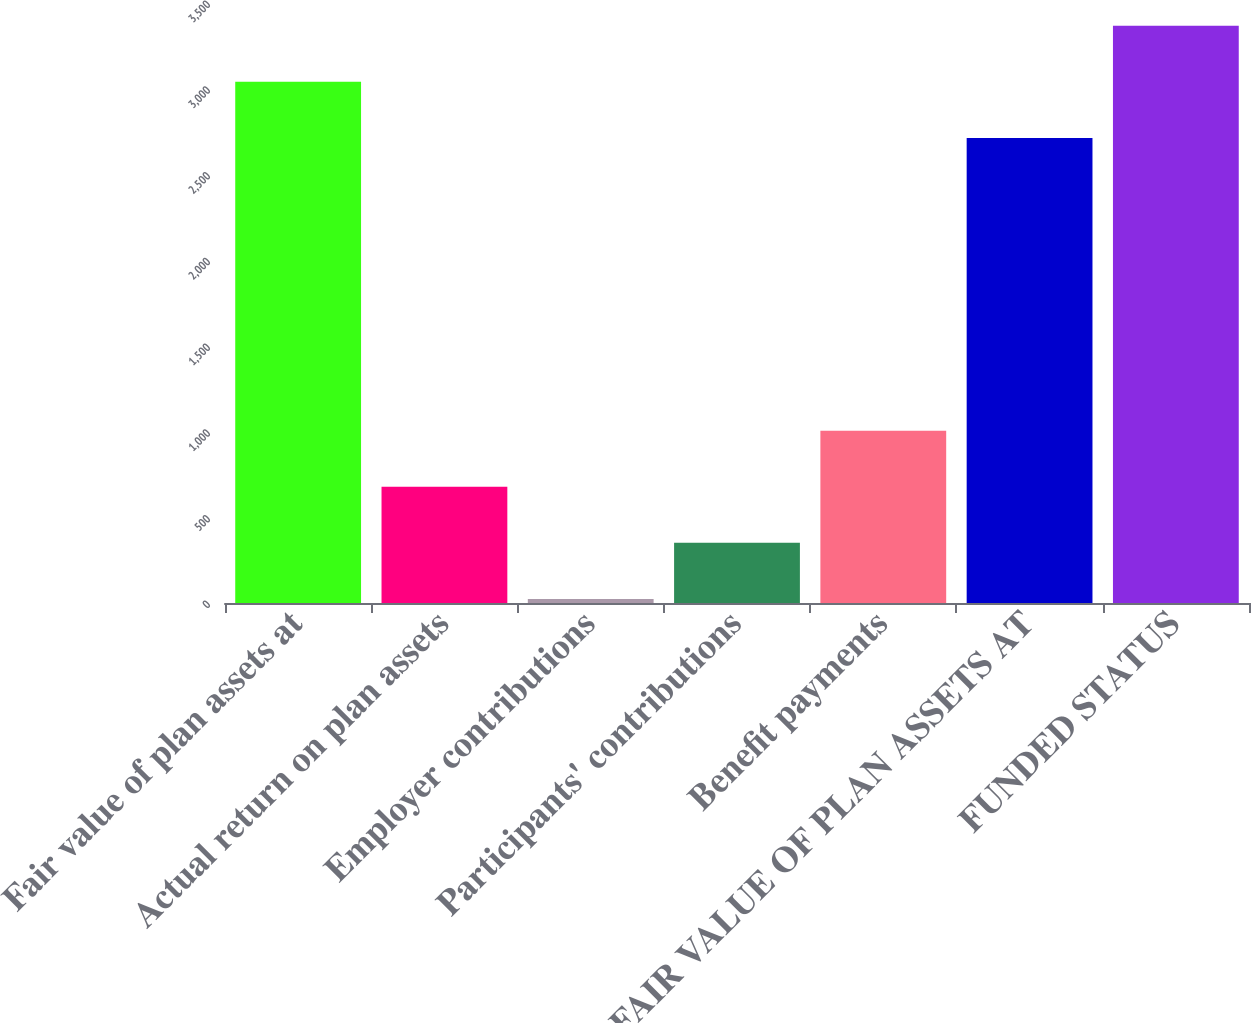<chart> <loc_0><loc_0><loc_500><loc_500><bar_chart><fcel>Fair value of plan assets at<fcel>Actual return on plan assets<fcel>Employer contributions<fcel>Participants' contributions<fcel>Benefit payments<fcel>FAIR VALUE OF PLAN ASSETS AT<fcel>FUNDED STATUS<nl><fcel>3039.9<fcel>677.8<fcel>24<fcel>350.9<fcel>1004.7<fcel>2713<fcel>3366.8<nl></chart> 